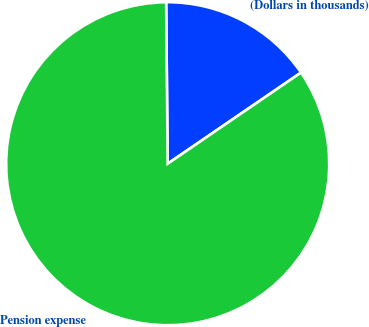Convert chart to OTSL. <chart><loc_0><loc_0><loc_500><loc_500><pie_chart><fcel>(Dollars in thousands)<fcel>Pension expense<nl><fcel>15.61%<fcel>84.39%<nl></chart> 